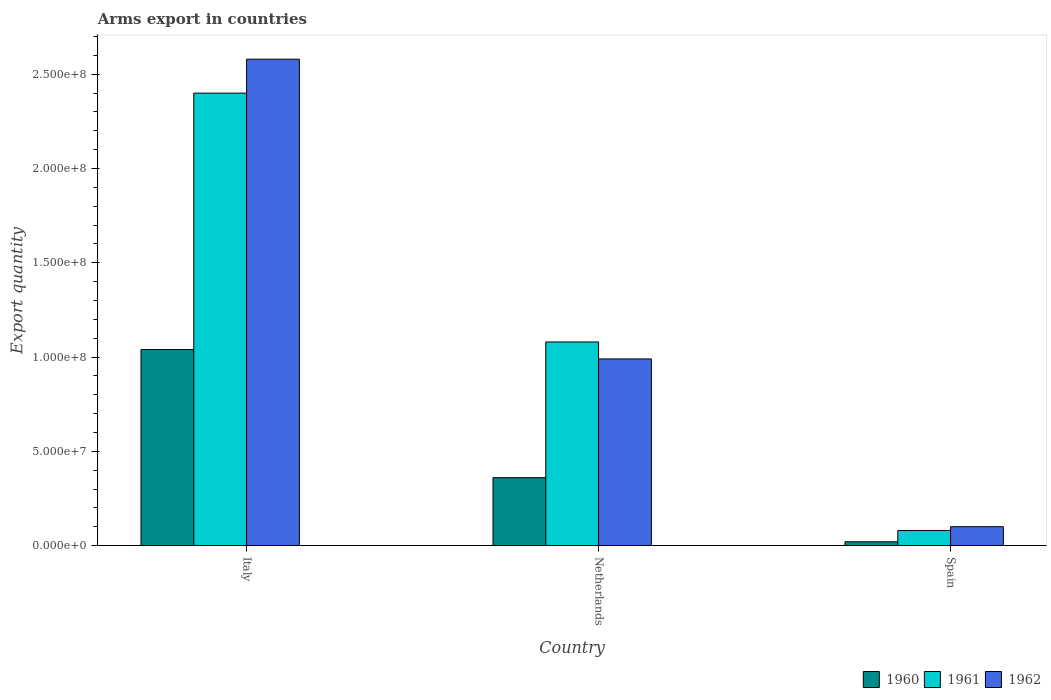Are the number of bars on each tick of the X-axis equal?
Make the answer very short. Yes. How many bars are there on the 1st tick from the left?
Offer a terse response. 3. How many bars are there on the 3rd tick from the right?
Keep it short and to the point. 3. What is the label of the 1st group of bars from the left?
Ensure brevity in your answer.  Italy. In how many cases, is the number of bars for a given country not equal to the number of legend labels?
Your answer should be very brief. 0. What is the total arms export in 1961 in Spain?
Make the answer very short. 8.00e+06. Across all countries, what is the maximum total arms export in 1961?
Your answer should be very brief. 2.40e+08. Across all countries, what is the minimum total arms export in 1961?
Ensure brevity in your answer.  8.00e+06. In which country was the total arms export in 1960 maximum?
Your response must be concise. Italy. What is the total total arms export in 1960 in the graph?
Your answer should be compact. 1.42e+08. What is the difference between the total arms export in 1962 in Italy and that in Spain?
Your answer should be compact. 2.48e+08. What is the difference between the total arms export in 1961 in Spain and the total arms export in 1960 in Italy?
Offer a very short reply. -9.60e+07. What is the average total arms export in 1962 per country?
Ensure brevity in your answer.  1.22e+08. What is the difference between the total arms export of/in 1961 and total arms export of/in 1962 in Netherlands?
Make the answer very short. 9.00e+06. What is the ratio of the total arms export in 1962 in Italy to that in Spain?
Offer a terse response. 25.8. Is the difference between the total arms export in 1961 in Italy and Spain greater than the difference between the total arms export in 1962 in Italy and Spain?
Give a very brief answer. No. What is the difference between the highest and the second highest total arms export in 1961?
Offer a terse response. 1.32e+08. What is the difference between the highest and the lowest total arms export in 1961?
Ensure brevity in your answer.  2.32e+08. Is the sum of the total arms export in 1962 in Italy and Spain greater than the maximum total arms export in 1960 across all countries?
Keep it short and to the point. Yes. What does the 1st bar from the right in Netherlands represents?
Offer a very short reply. 1962. Are all the bars in the graph horizontal?
Your answer should be compact. No. Does the graph contain grids?
Make the answer very short. No. Where does the legend appear in the graph?
Provide a succinct answer. Bottom right. How many legend labels are there?
Offer a terse response. 3. How are the legend labels stacked?
Offer a very short reply. Horizontal. What is the title of the graph?
Give a very brief answer. Arms export in countries. Does "1970" appear as one of the legend labels in the graph?
Ensure brevity in your answer.  No. What is the label or title of the Y-axis?
Your response must be concise. Export quantity. What is the Export quantity in 1960 in Italy?
Your response must be concise. 1.04e+08. What is the Export quantity in 1961 in Italy?
Ensure brevity in your answer.  2.40e+08. What is the Export quantity of 1962 in Italy?
Your answer should be compact. 2.58e+08. What is the Export quantity of 1960 in Netherlands?
Keep it short and to the point. 3.60e+07. What is the Export quantity of 1961 in Netherlands?
Offer a very short reply. 1.08e+08. What is the Export quantity in 1962 in Netherlands?
Your answer should be very brief. 9.90e+07. What is the Export quantity of 1960 in Spain?
Your answer should be very brief. 2.00e+06. What is the Export quantity of 1962 in Spain?
Keep it short and to the point. 1.00e+07. Across all countries, what is the maximum Export quantity in 1960?
Make the answer very short. 1.04e+08. Across all countries, what is the maximum Export quantity in 1961?
Your answer should be very brief. 2.40e+08. Across all countries, what is the maximum Export quantity of 1962?
Keep it short and to the point. 2.58e+08. Across all countries, what is the minimum Export quantity in 1960?
Provide a short and direct response. 2.00e+06. Across all countries, what is the minimum Export quantity of 1961?
Offer a very short reply. 8.00e+06. What is the total Export quantity in 1960 in the graph?
Ensure brevity in your answer.  1.42e+08. What is the total Export quantity of 1961 in the graph?
Your answer should be very brief. 3.56e+08. What is the total Export quantity of 1962 in the graph?
Your answer should be very brief. 3.67e+08. What is the difference between the Export quantity of 1960 in Italy and that in Netherlands?
Ensure brevity in your answer.  6.80e+07. What is the difference between the Export quantity of 1961 in Italy and that in Netherlands?
Provide a succinct answer. 1.32e+08. What is the difference between the Export quantity in 1962 in Italy and that in Netherlands?
Provide a succinct answer. 1.59e+08. What is the difference between the Export quantity of 1960 in Italy and that in Spain?
Offer a very short reply. 1.02e+08. What is the difference between the Export quantity in 1961 in Italy and that in Spain?
Ensure brevity in your answer.  2.32e+08. What is the difference between the Export quantity of 1962 in Italy and that in Spain?
Give a very brief answer. 2.48e+08. What is the difference between the Export quantity in 1960 in Netherlands and that in Spain?
Give a very brief answer. 3.40e+07. What is the difference between the Export quantity in 1961 in Netherlands and that in Spain?
Provide a short and direct response. 1.00e+08. What is the difference between the Export quantity of 1962 in Netherlands and that in Spain?
Your answer should be very brief. 8.90e+07. What is the difference between the Export quantity in 1960 in Italy and the Export quantity in 1962 in Netherlands?
Your answer should be compact. 5.00e+06. What is the difference between the Export quantity of 1961 in Italy and the Export quantity of 1962 in Netherlands?
Keep it short and to the point. 1.41e+08. What is the difference between the Export quantity of 1960 in Italy and the Export quantity of 1961 in Spain?
Offer a very short reply. 9.60e+07. What is the difference between the Export quantity in 1960 in Italy and the Export quantity in 1962 in Spain?
Keep it short and to the point. 9.40e+07. What is the difference between the Export quantity of 1961 in Italy and the Export quantity of 1962 in Spain?
Provide a succinct answer. 2.30e+08. What is the difference between the Export quantity in 1960 in Netherlands and the Export quantity in 1961 in Spain?
Provide a succinct answer. 2.80e+07. What is the difference between the Export quantity of 1960 in Netherlands and the Export quantity of 1962 in Spain?
Give a very brief answer. 2.60e+07. What is the difference between the Export quantity of 1961 in Netherlands and the Export quantity of 1962 in Spain?
Give a very brief answer. 9.80e+07. What is the average Export quantity of 1960 per country?
Your response must be concise. 4.73e+07. What is the average Export quantity in 1961 per country?
Provide a succinct answer. 1.19e+08. What is the average Export quantity in 1962 per country?
Provide a succinct answer. 1.22e+08. What is the difference between the Export quantity in 1960 and Export quantity in 1961 in Italy?
Your response must be concise. -1.36e+08. What is the difference between the Export quantity in 1960 and Export quantity in 1962 in Italy?
Provide a succinct answer. -1.54e+08. What is the difference between the Export quantity of 1961 and Export quantity of 1962 in Italy?
Provide a succinct answer. -1.80e+07. What is the difference between the Export quantity of 1960 and Export quantity of 1961 in Netherlands?
Your answer should be compact. -7.20e+07. What is the difference between the Export quantity in 1960 and Export quantity in 1962 in Netherlands?
Keep it short and to the point. -6.30e+07. What is the difference between the Export quantity in 1961 and Export quantity in 1962 in Netherlands?
Your answer should be very brief. 9.00e+06. What is the difference between the Export quantity of 1960 and Export quantity of 1961 in Spain?
Provide a short and direct response. -6.00e+06. What is the difference between the Export quantity of 1960 and Export quantity of 1962 in Spain?
Keep it short and to the point. -8.00e+06. What is the ratio of the Export quantity in 1960 in Italy to that in Netherlands?
Make the answer very short. 2.89. What is the ratio of the Export quantity in 1961 in Italy to that in Netherlands?
Your answer should be very brief. 2.22. What is the ratio of the Export quantity in 1962 in Italy to that in Netherlands?
Your answer should be compact. 2.61. What is the ratio of the Export quantity of 1960 in Italy to that in Spain?
Provide a succinct answer. 52. What is the ratio of the Export quantity in 1962 in Italy to that in Spain?
Provide a succinct answer. 25.8. What is the ratio of the Export quantity in 1960 in Netherlands to that in Spain?
Keep it short and to the point. 18. What is the ratio of the Export quantity in 1962 in Netherlands to that in Spain?
Keep it short and to the point. 9.9. What is the difference between the highest and the second highest Export quantity in 1960?
Give a very brief answer. 6.80e+07. What is the difference between the highest and the second highest Export quantity of 1961?
Your answer should be very brief. 1.32e+08. What is the difference between the highest and the second highest Export quantity of 1962?
Provide a short and direct response. 1.59e+08. What is the difference between the highest and the lowest Export quantity of 1960?
Give a very brief answer. 1.02e+08. What is the difference between the highest and the lowest Export quantity in 1961?
Your response must be concise. 2.32e+08. What is the difference between the highest and the lowest Export quantity in 1962?
Offer a very short reply. 2.48e+08. 